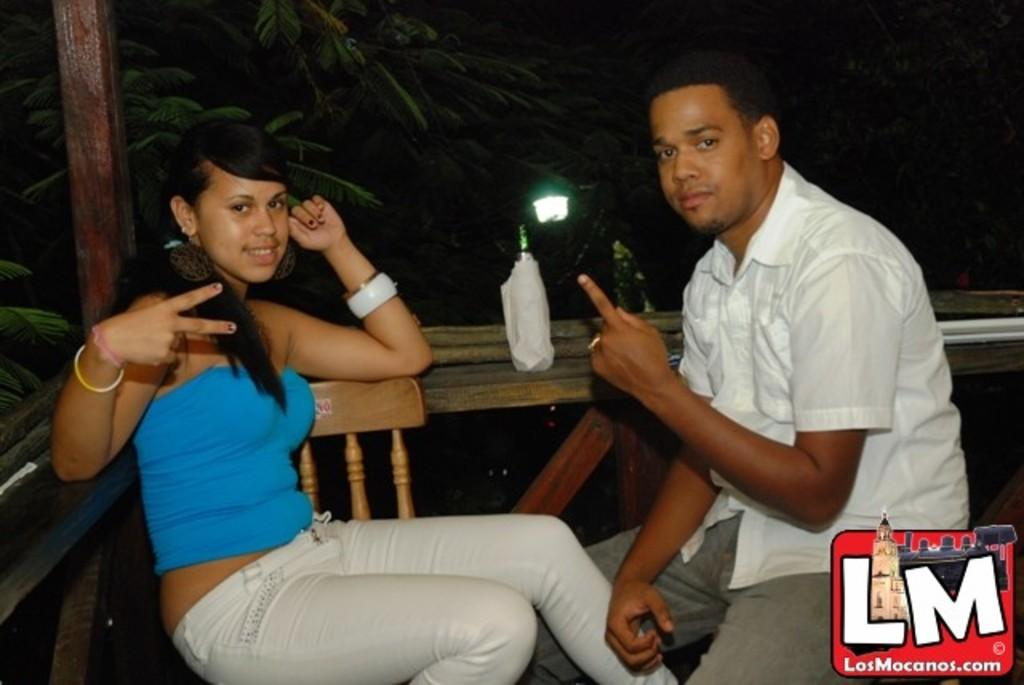How many people are present in the image? There is a woman and a man present in the image. What are the woman and the man doing in the image? Both the woman and the man are sitting in chairs. What can be seen in the background of the image? There is a table, a bottle, a light, trees, and a pole in the background of the image. How many children are playing on the plane in the image? There is no plane or children present in the image. What type of pull can be seen in the image? There is no pull visible in the image. 